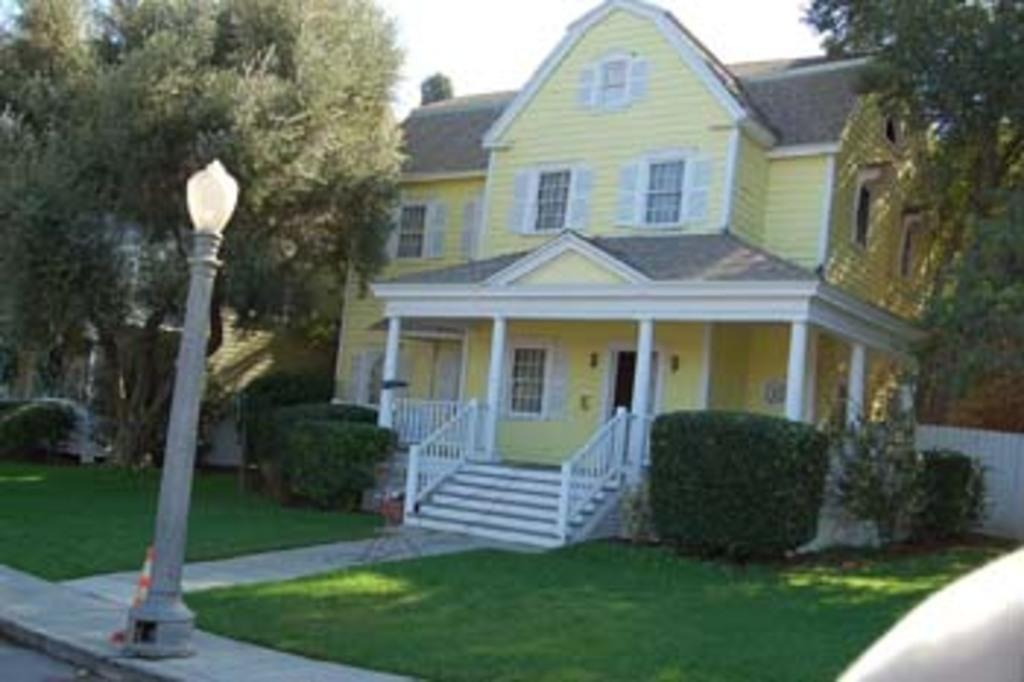What structure can be seen in the image? There is a light pole in the image. What type of vegetation is present in the image? There is grass, plants, and trees in the image. What type of building is visible in the image? There is a house in the image. What is visible in the background of the image? The sky is visible in the background of the image. What type of chalk is being used to draw on the grass in the image? There is no chalk or drawing activity present in the image. What type of polish is being applied to the trees in the image? There is no polish or application activity present in the image. 